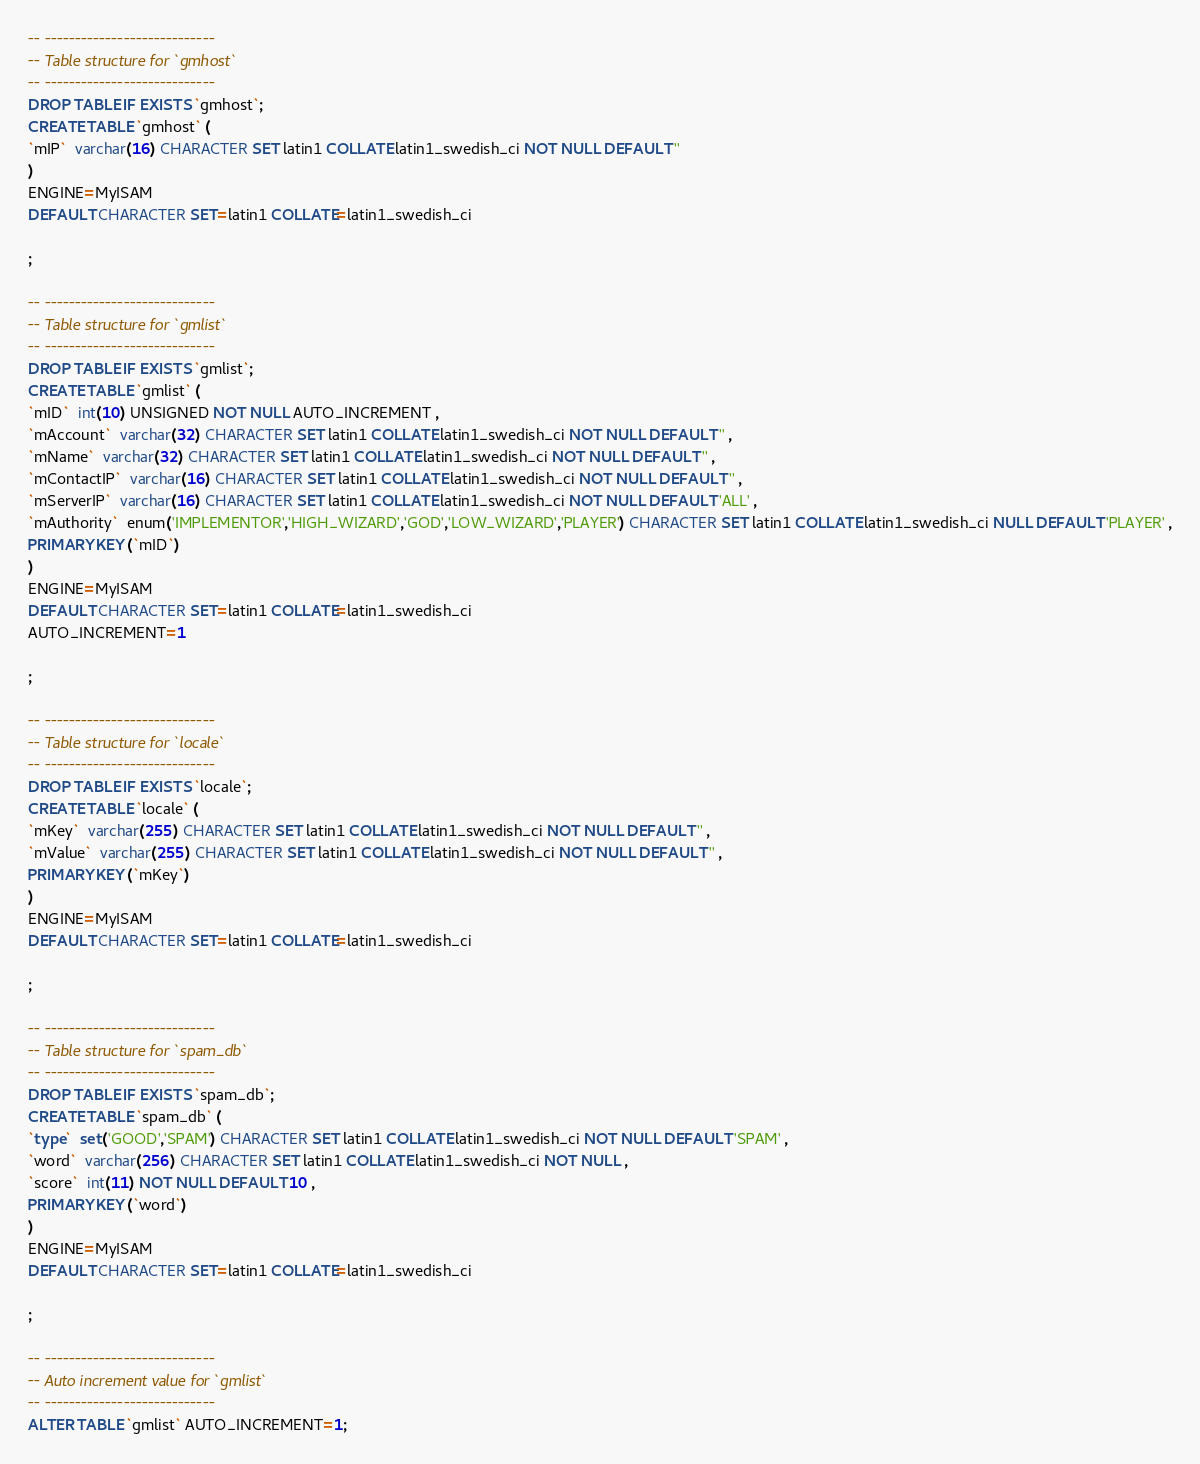<code> <loc_0><loc_0><loc_500><loc_500><_SQL_>-- ----------------------------
-- Table structure for `gmhost`
-- ----------------------------
DROP TABLE IF EXISTS `gmhost`;
CREATE TABLE `gmhost` (
`mIP`  varchar(16) CHARACTER SET latin1 COLLATE latin1_swedish_ci NOT NULL DEFAULT '' 
)
ENGINE=MyISAM
DEFAULT CHARACTER SET=latin1 COLLATE=latin1_swedish_ci

;

-- ----------------------------
-- Table structure for `gmlist`
-- ----------------------------
DROP TABLE IF EXISTS `gmlist`;
CREATE TABLE `gmlist` (
`mID`  int(10) UNSIGNED NOT NULL AUTO_INCREMENT ,
`mAccount`  varchar(32) CHARACTER SET latin1 COLLATE latin1_swedish_ci NOT NULL DEFAULT '' ,
`mName`  varchar(32) CHARACTER SET latin1 COLLATE latin1_swedish_ci NOT NULL DEFAULT '' ,
`mContactIP`  varchar(16) CHARACTER SET latin1 COLLATE latin1_swedish_ci NOT NULL DEFAULT '' ,
`mServerIP`  varchar(16) CHARACTER SET latin1 COLLATE latin1_swedish_ci NOT NULL DEFAULT 'ALL' ,
`mAuthority`  enum('IMPLEMENTOR','HIGH_WIZARD','GOD','LOW_WIZARD','PLAYER') CHARACTER SET latin1 COLLATE latin1_swedish_ci NULL DEFAULT 'PLAYER' ,
PRIMARY KEY (`mID`)
)
ENGINE=MyISAM
DEFAULT CHARACTER SET=latin1 COLLATE=latin1_swedish_ci
AUTO_INCREMENT=1

;

-- ----------------------------
-- Table structure for `locale`
-- ----------------------------
DROP TABLE IF EXISTS `locale`;
CREATE TABLE `locale` (
`mKey`  varchar(255) CHARACTER SET latin1 COLLATE latin1_swedish_ci NOT NULL DEFAULT '' ,
`mValue`  varchar(255) CHARACTER SET latin1 COLLATE latin1_swedish_ci NOT NULL DEFAULT '' ,
PRIMARY KEY (`mKey`)
)
ENGINE=MyISAM
DEFAULT CHARACTER SET=latin1 COLLATE=latin1_swedish_ci

;

-- ----------------------------
-- Table structure for `spam_db`
-- ----------------------------
DROP TABLE IF EXISTS `spam_db`;
CREATE TABLE `spam_db` (
`type`  set('GOOD','SPAM') CHARACTER SET latin1 COLLATE latin1_swedish_ci NOT NULL DEFAULT 'SPAM' ,
`word`  varchar(256) CHARACTER SET latin1 COLLATE latin1_swedish_ci NOT NULL ,
`score`  int(11) NOT NULL DEFAULT 10 ,
PRIMARY KEY (`word`)
)
ENGINE=MyISAM
DEFAULT CHARACTER SET=latin1 COLLATE=latin1_swedish_ci

;

-- ----------------------------
-- Auto increment value for `gmlist`
-- ----------------------------
ALTER TABLE `gmlist` AUTO_INCREMENT=1;
</code> 